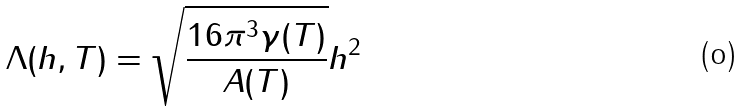Convert formula to latex. <formula><loc_0><loc_0><loc_500><loc_500>\Lambda ( h , T ) = \sqrt { \frac { 1 6 \pi ^ { 3 } \gamma ( T ) } { A ( T ) } } h ^ { 2 }</formula> 